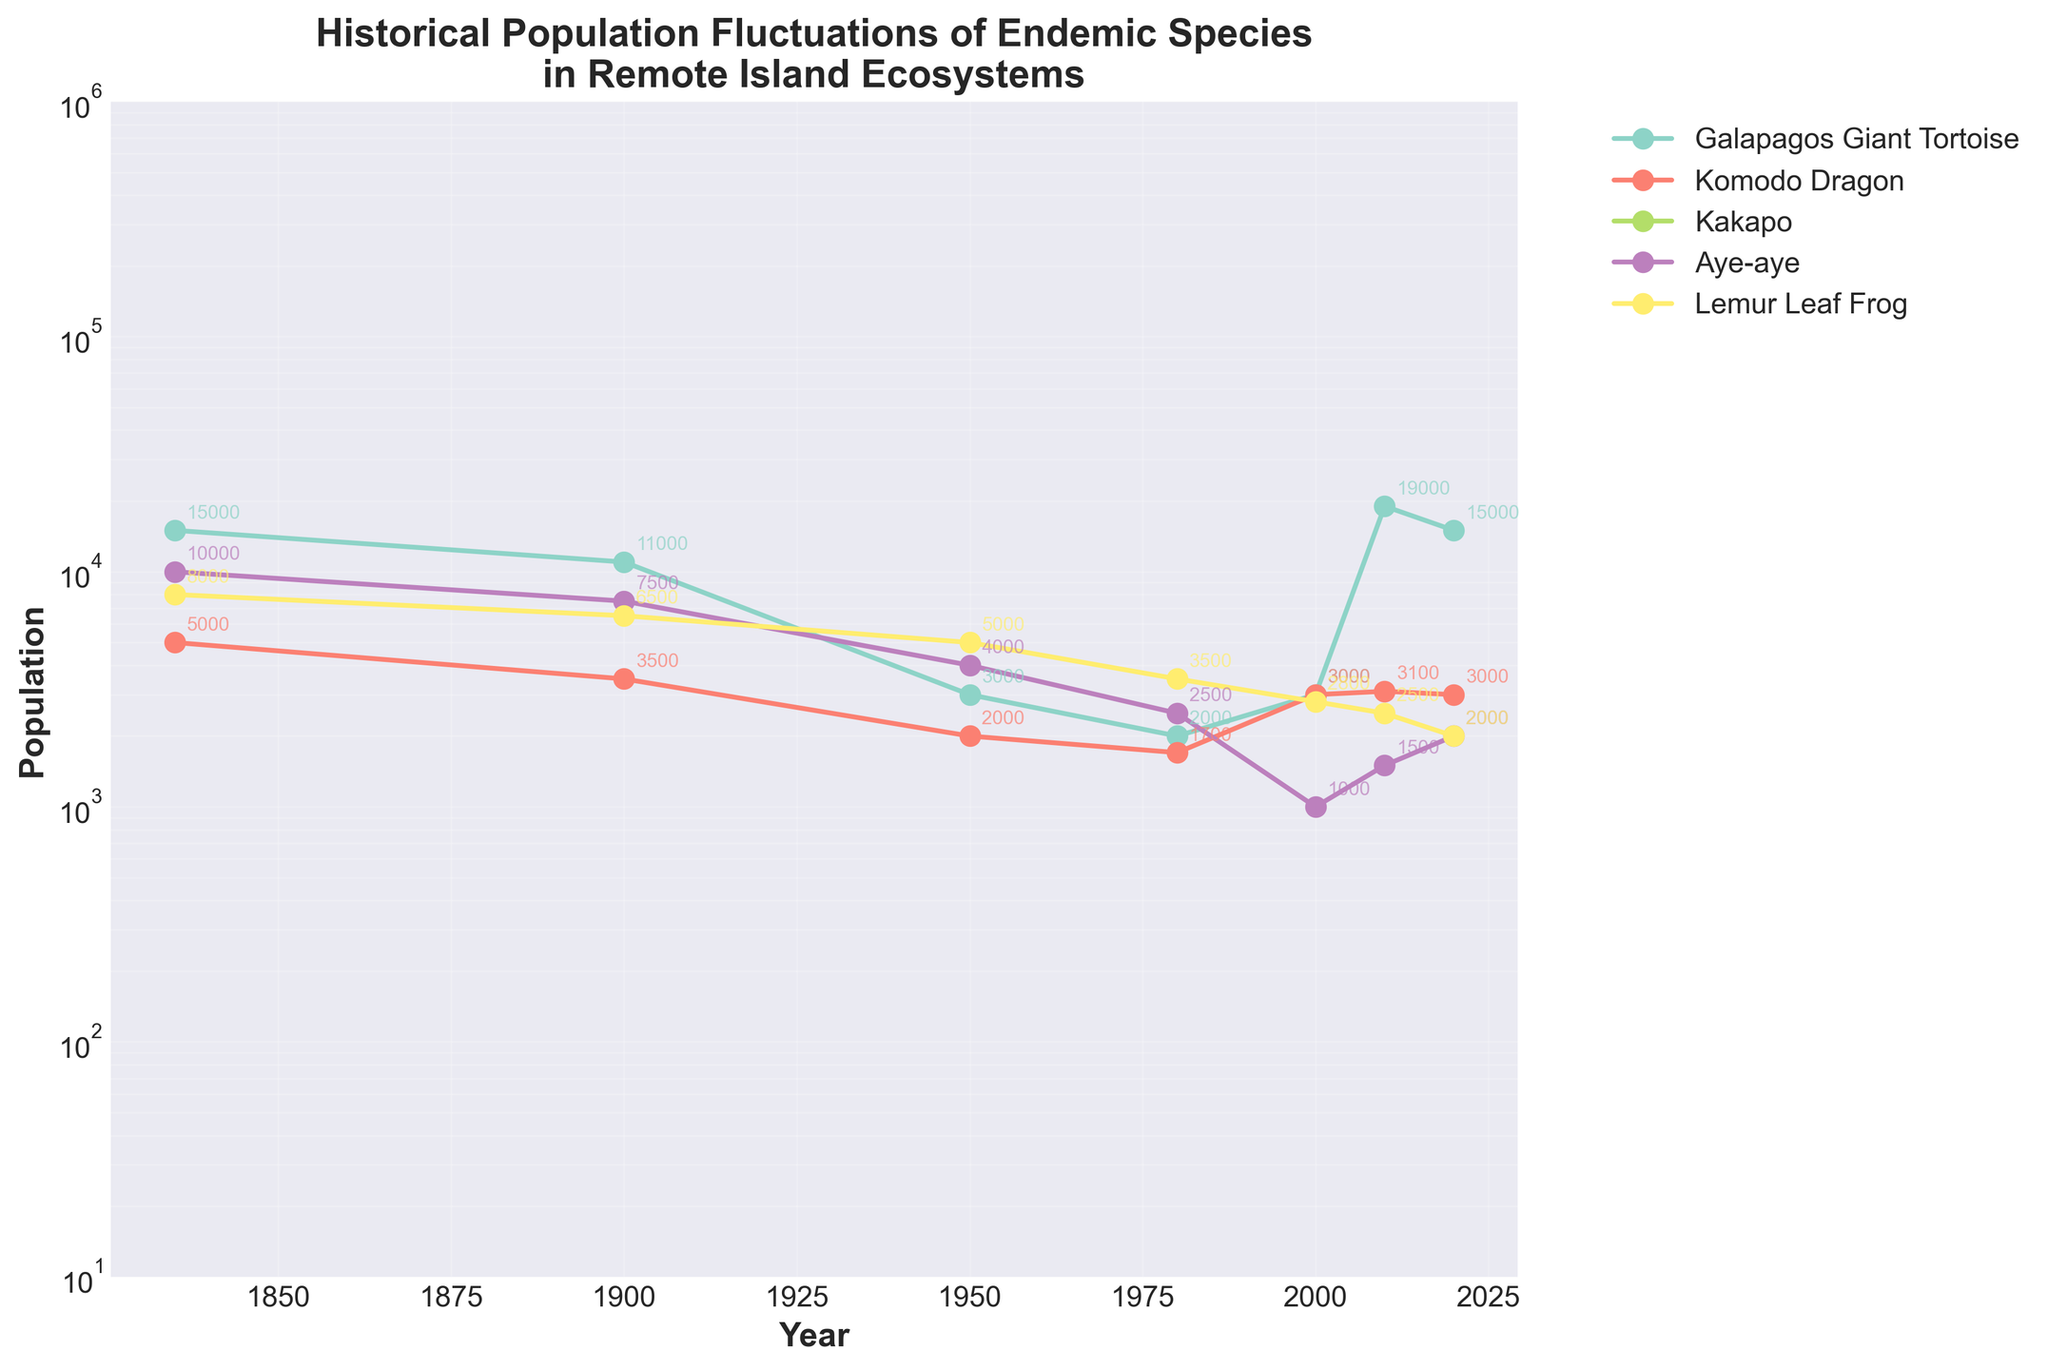What is the population trend of the Galapagos Giant Tortoise from 1835 to 2020? Initially, the population was 15000 in 1835, which decreased to 11000 by 1900, continued declining to 3000 by 1950, and dipped to 2000 in 1980. It then increased to 3000 by 2000, spiked to 19000 by 2010, and finally settled back to 15000 in 2020.
Answer: Decline, rise, decline Which species had the highest population in 2000 and what was its population? In the year 2000, the Galapagos Giant Tortoise had the highest population of 3000 when comparing the numerical values of all listed species for that year.
Answer: Galapagos Giant Tortoise, 3000 How does the population change of the Kakapo between 1980 and 2020 compare to the Aye-aye in the same time period? The Kakapo population started at 200 in 1980, reduced to 62 by 2000, and then increased to 201 by 2020. The Aye-aye population started at 2500 in 1980, decreased to 1000 by 2000, and showed a slight increase to 2000 by 2020.
Answer: Both showed a decline and then a recovery What can you infer about the trend in the Komodo Dragon population from 1950 to 2020? From 1950, the population decreased from 2000 to 1700 in 1980. Then it increased to 3000 by 2000, slightly changed to 3100 in 2010, and settled back to 3000 in 2020.
Answer: Decrease, increase, then stabilize Which year experienced the steepest decline in the Lemur Leaf Frog population, and what was the prior and subsequent population? From 1900 to 1950, the population decreased from 6500 to 5000, representing the steepest decline of 1500 in any period recorded.
Answer: 1950, 6500, 5000 What is the average population of the Aye-aye from 1980 to 2020? Adding populations from 1980 (2500), 2000 (1000), 2010 (1500), and 2020 (2000) gives a total of 7000. Dividing by four, the average is 1750.
Answer: 1750 Which species had the most variable population changes between 1835 and 2020? The Galapagos Giant Tortoise fluctuated markedly with major declines and significant peaks throughout the period, indicating high variability.
Answer: Galapagos Giant Tortoise How many species had an increased population from 1980 to 2020? By comparing the populations in 1980 and 2020, the Galapagos Giant Tortoise (2000 to 15000), Kakapo (200 to 201), Aye-aye (2500 to 2000), and Komodo Dragon (1700 to 3000) show increases. The Lemur Leaf Frog decreased (3500 to 2000).
Answer: 4 species If the populations of the Galapagos Giant Tortoise and Aye-aye are combined, what is their total population in 2020? Adding the 2020 populations of Galapagos Giant Tortoise (15000) and Aye-aye (2000) results in a total combined population of 17000.
Answer: 17000 